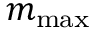<formula> <loc_0><loc_0><loc_500><loc_500>m _ { \max }</formula> 